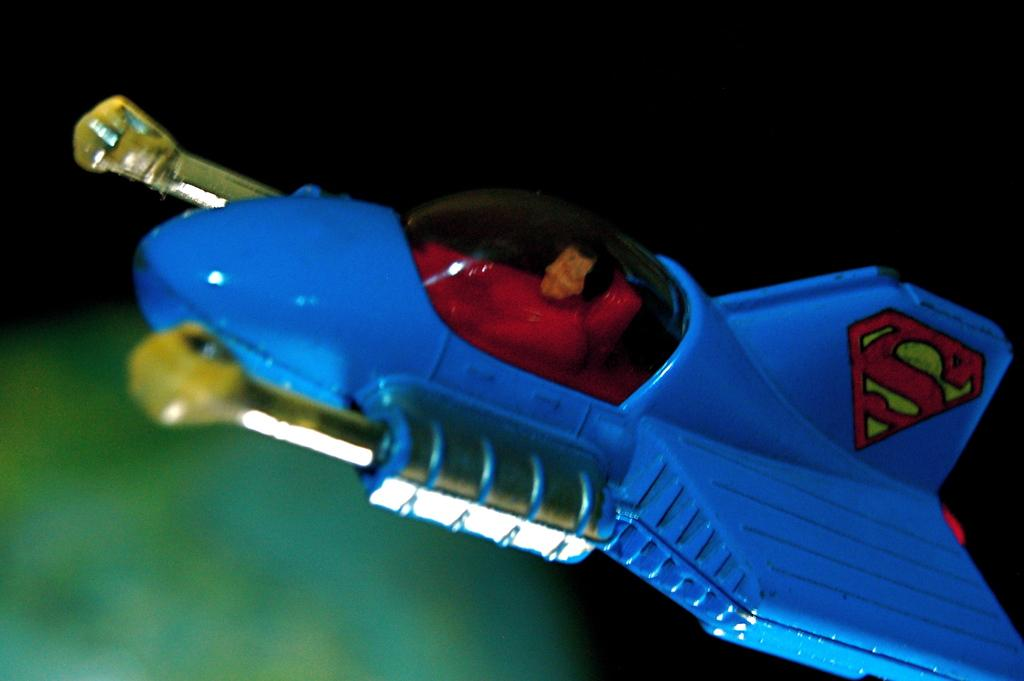<image>
Create a compact narrative representing the image presented. The toy jet plane has the Superman S on it's tail. 